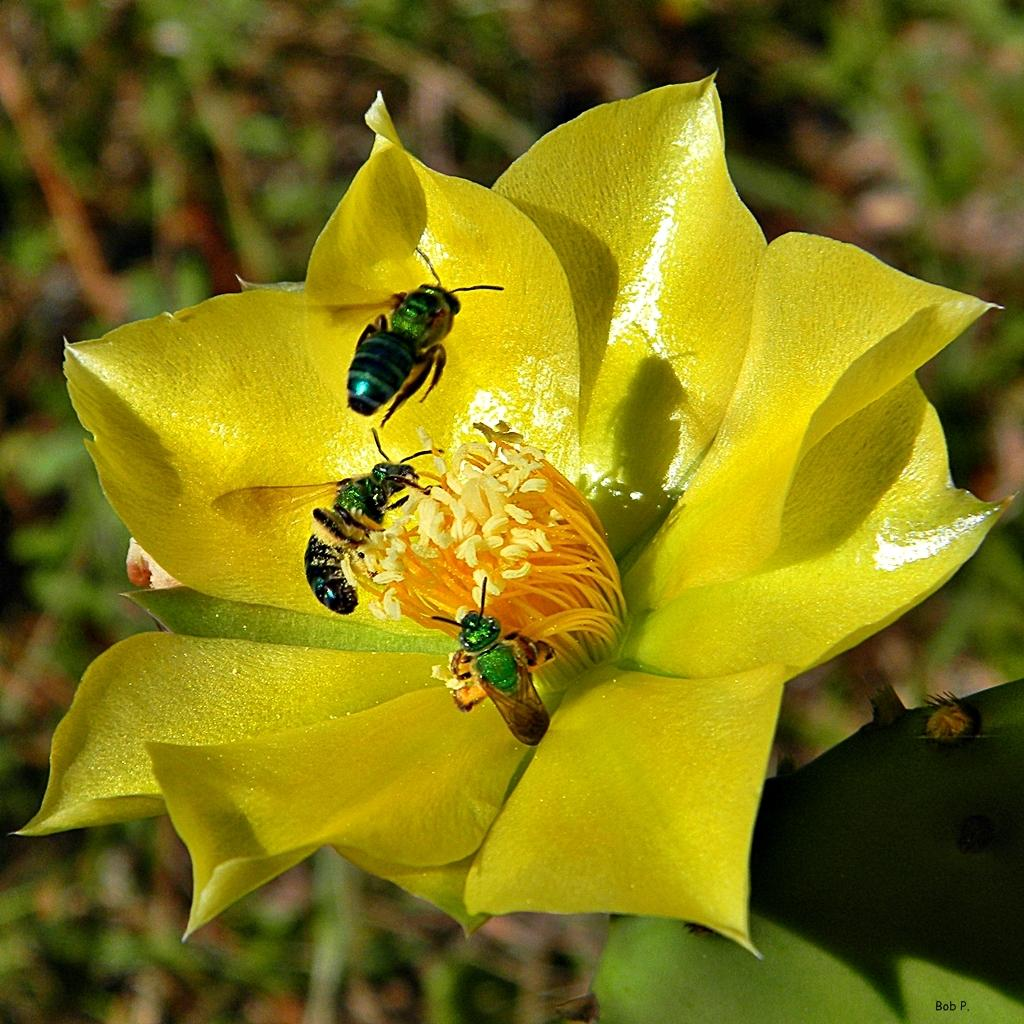What is the main subject of the image? The main subject of the image is insects on a flower. Can you describe the setting of the image? There are leaves visible in the background of the image. What type of lawyer is sitting on the flower in the image? There are no lawyers present in the image; it features insects on a flower. Can you see a nest in the image? There is no nest visible in the image; it only shows insects on a flower and leaves in the background. 